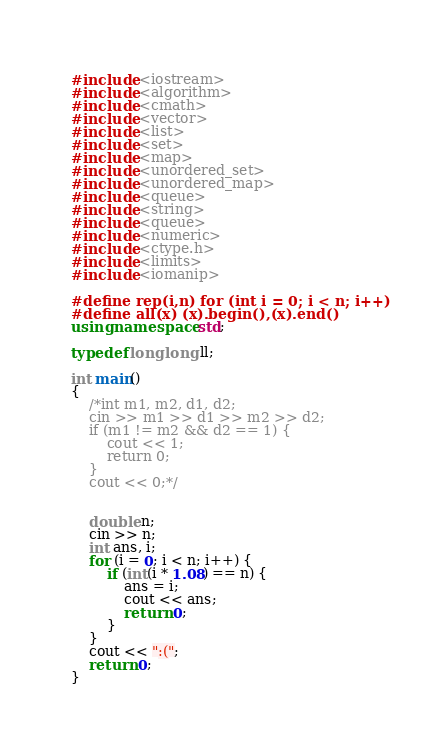Convert code to text. <code><loc_0><loc_0><loc_500><loc_500><_C++_>#include <iostream>
#include <algorithm>
#include <cmath>
#include <vector>
#include <list>
#include <set>
#include <map>
#include <unordered_set>
#include <unordered_map>
#include <queue>
#include <string>
#include <queue>
#include <numeric>
#include <ctype.h>
#include <limits>
#include <iomanip>

#define rep(i,n) for (int i = 0; i < n; i++)
#define all(x) (x).begin(),(x).end()
using namespace std;

typedef long long ll;

int main()
{
	/*int m1, m2, d1, d2;
	cin >> m1 >> d1 >> m2 >> d2;
	if (m1 != m2 && d2 == 1) {
		cout << 1;
		return 0;
	}
	cout << 0;*/


	double n;
	cin >> n;
	int ans, i;
	for (i = 0; i < n; i++) {
		if (int(i * 1.08) == n) {
			ans = i;
			cout << ans;
			return 0;
		}
	}
	cout << ":(";
	return 0;
}</code> 